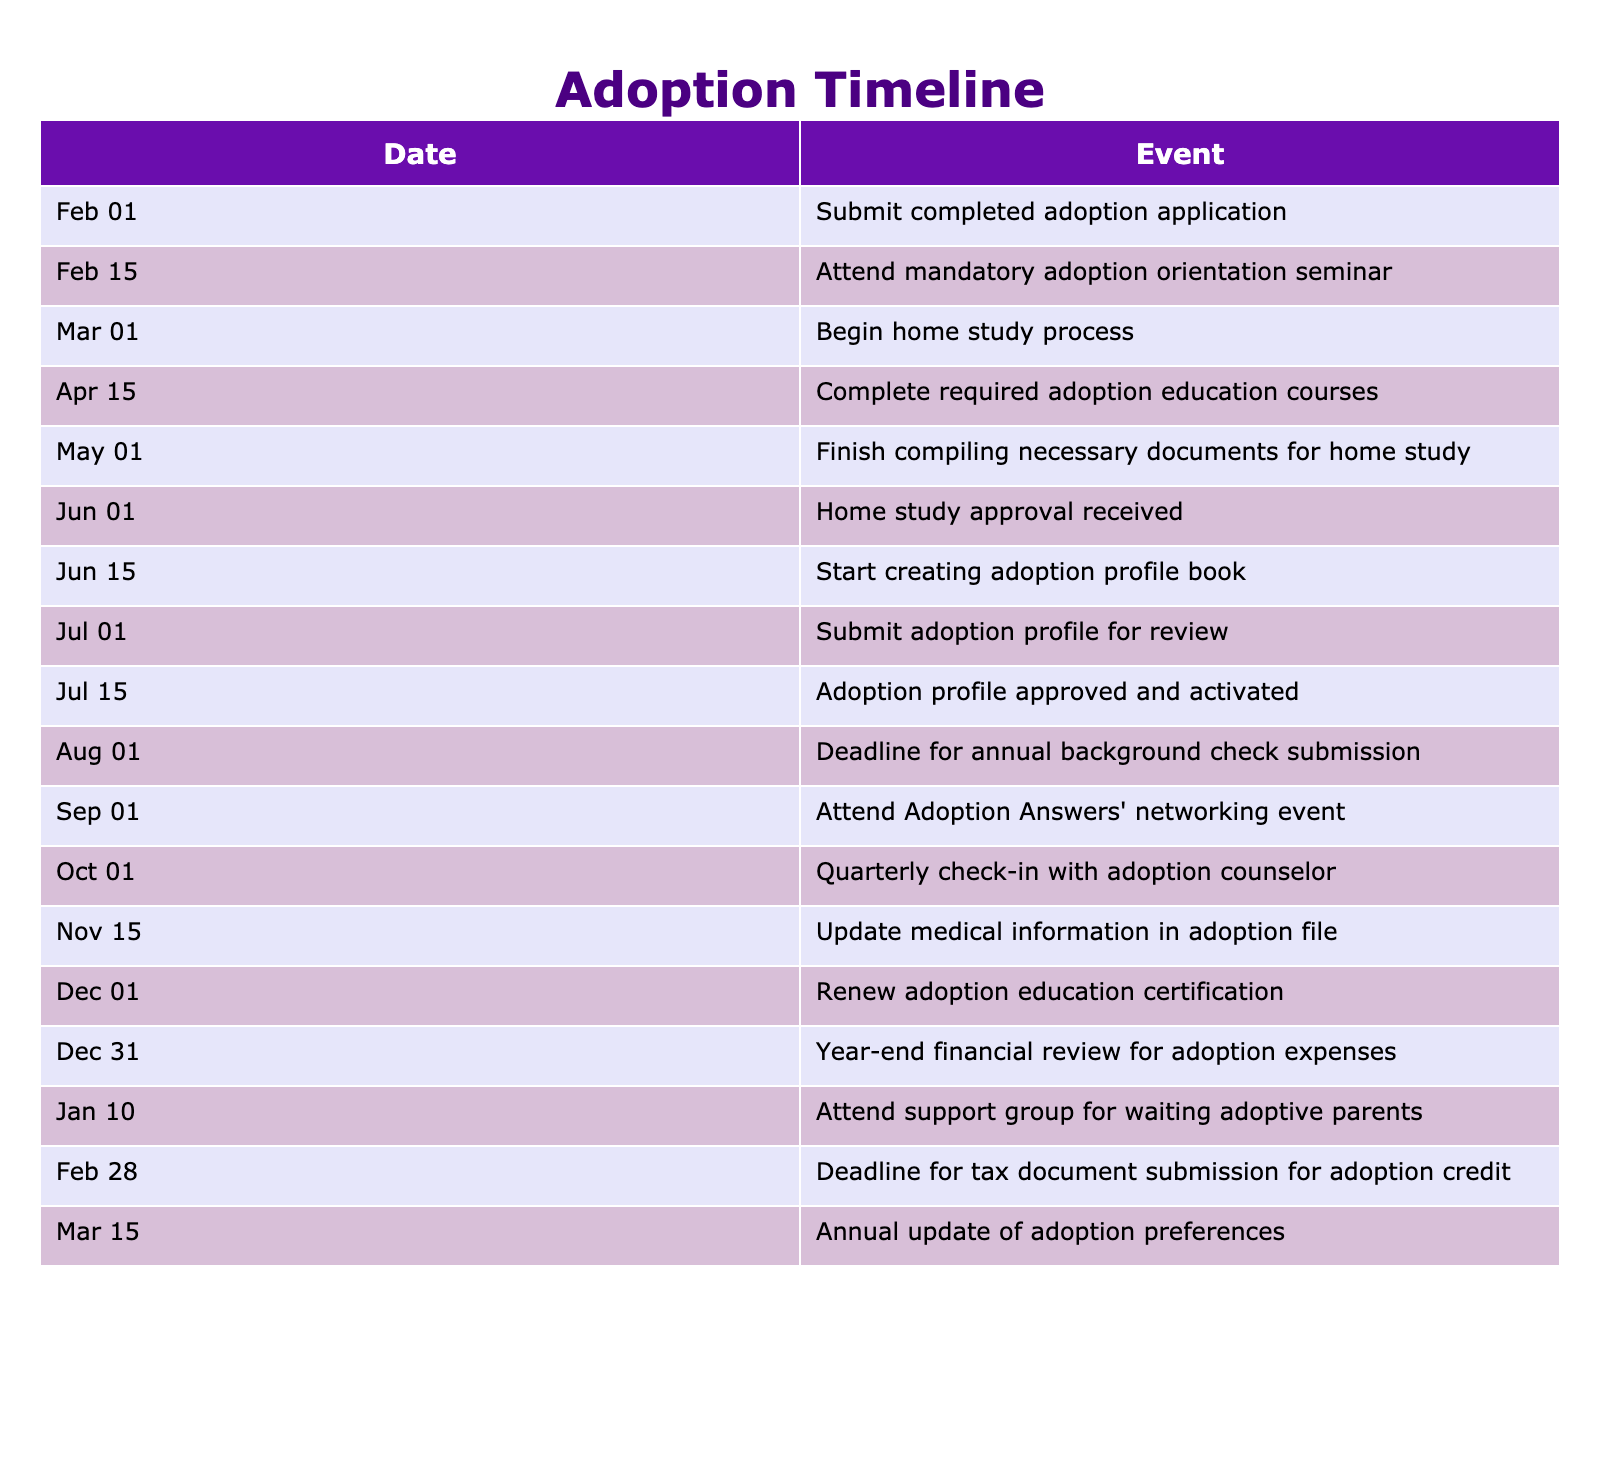What is the first event listed in the timeline? The first event is the submission of the completed adoption application on February 1. This can be observed by scanning the "Event" column for the first entry paired with its corresponding date.
Answer: Submit completed adoption application How many days are there between the adoption profile approval and the deadline for annual background check submission? The adoption profile is approved on July 15, and the deadline for the annual background check submission is August 1. There are 17 days between these two dates (from July 15 to August 1).
Answer: 17 days What is the last event listed in the timeline? The last event in the table is the annual update of adoption preferences on March 15. By looking at the final entry in the "Event" column, we can confirm this.
Answer: Annual update of adoption preferences Is there an event scheduled for September 1? Yes, there is an event on September 1: attendance at Adoption Answers' networking event. This is verified by the presence of this specific date in the "Date" column with its associated event.
Answer: Yes What are the two events that occur in February? The events in February are the submission of the completed adoption application on February 1 and attending the mandatory adoption orientation seminar on February 15. By reviewing the "Date" column for the month of February and their corresponding events, they can be identified.
Answer: Submit completed adoption application and Attend mandatory adoption orientation seminar What is the average number of days between major events (those that are spaced at least a month apart) based on the timeline? To find this, we identify major events: February 1 (application), March 1 (home study), April 15 (education courses), June 1 (home study approval), July 15 (profile approved), August 1 (background check), and calculate the number of days between each pair that are more than a month apart. The differences in days are 28, 15, 46, 44, 16, and so on. By summing these intervals and dividing by the number of intervals, we can find the average, which is 36 days. This requires both identifying major gaps and performing the mathematical operations.
Answer: 36 days How many total events occur before the adoption profile is submitted? The events before the submission of the adoption profile on July 1 include: application, orientation, home study process, education courses, document compilation, home study approval, and profile book creation. This totals to six events, identifiable by counting the rows with dates before July 1.
Answer: 6 events Are there any events scheduled in December? Yes, there are two events scheduled in December: renewing the adoption education certification on December 1 and year-end financial review for adoption expenses on December 31. Checking the table for December dates confirms this.
Answer: Yes 